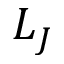Convert formula to latex. <formula><loc_0><loc_0><loc_500><loc_500>L _ { J }</formula> 